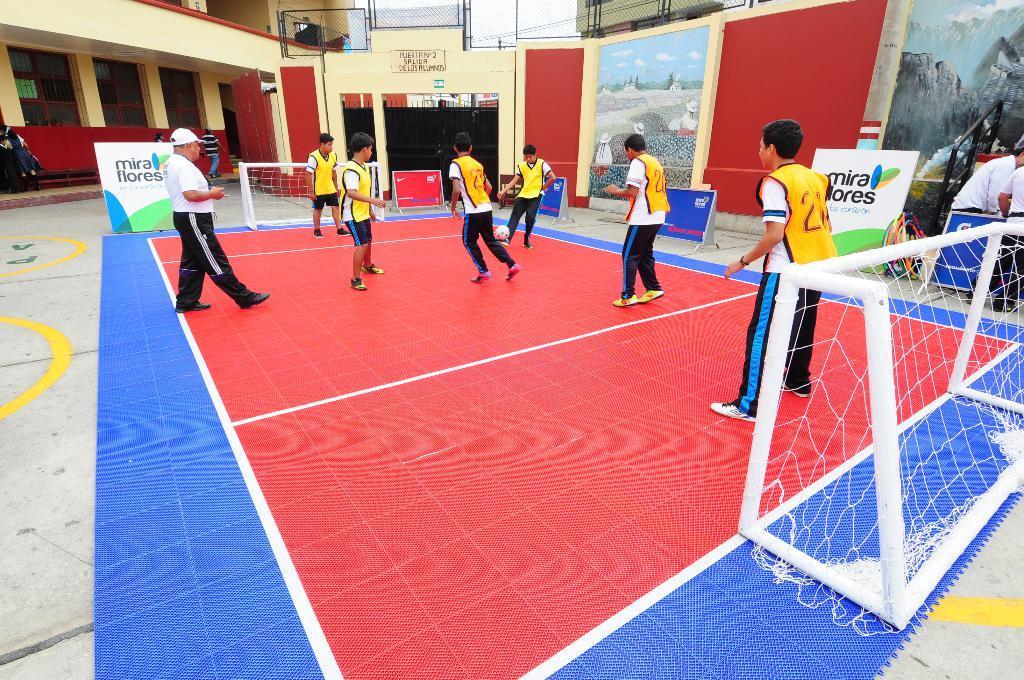Could you give a brief overview of what you see in this image? In this picture there are few people standing on a red color ground and there is a net on either sides of them and there is a building and some other objects in the background. 